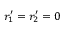<formula> <loc_0><loc_0><loc_500><loc_500>r _ { 1 } ^ { \prime } = r _ { 2 } ^ { \prime } = 0</formula> 